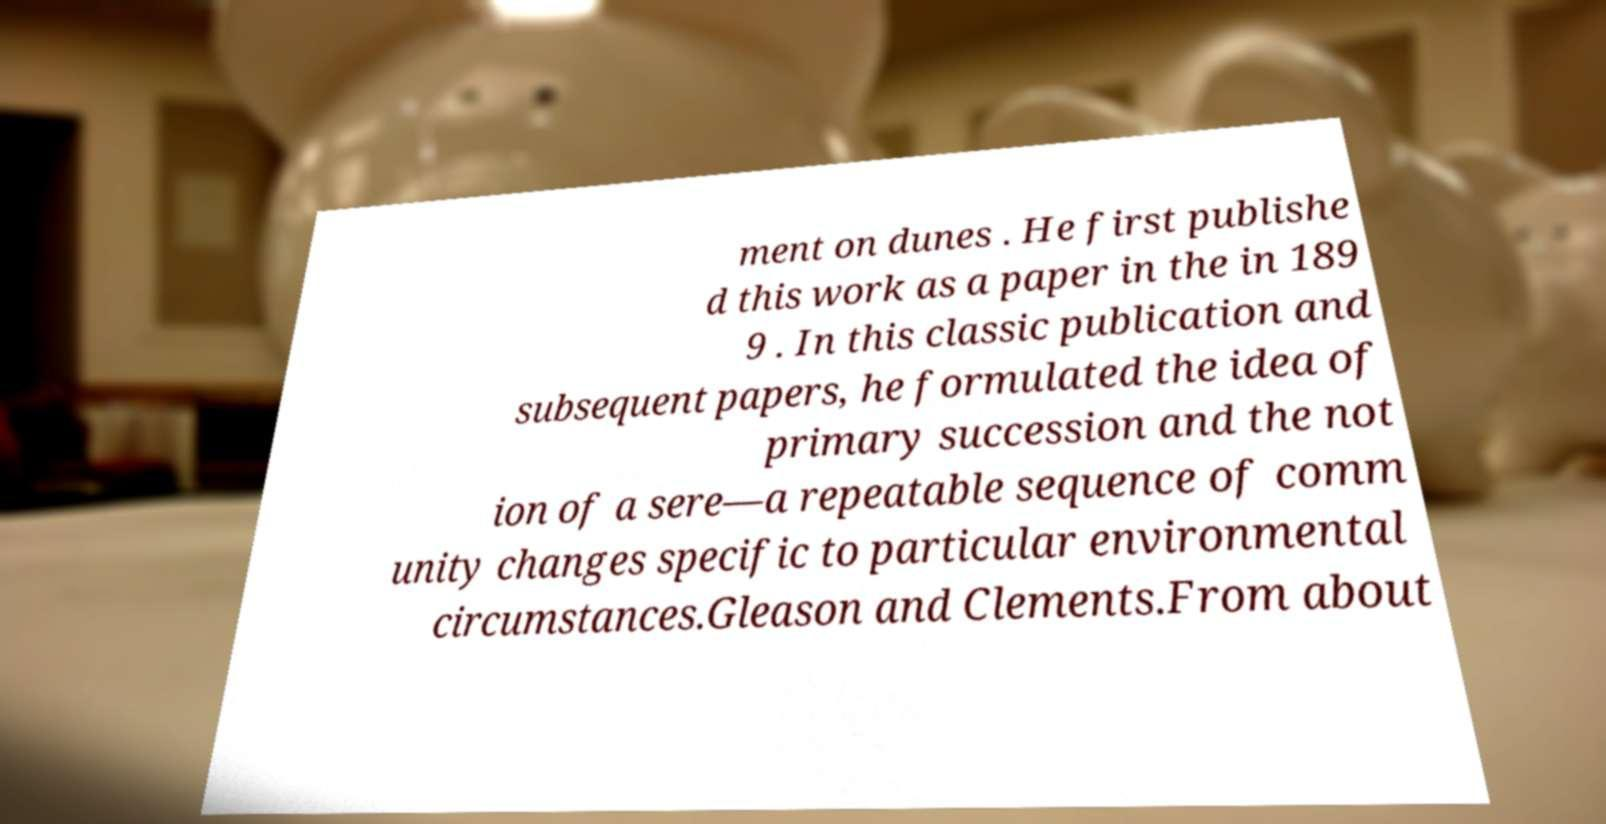Please read and relay the text visible in this image. What does it say? ment on dunes . He first publishe d this work as a paper in the in 189 9 . In this classic publication and subsequent papers, he formulated the idea of primary succession and the not ion of a sere—a repeatable sequence of comm unity changes specific to particular environmental circumstances.Gleason and Clements.From about 